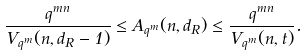Convert formula to latex. <formula><loc_0><loc_0><loc_500><loc_500>\frac { q ^ { m n } } { V _ { q ^ { m } } ( n , d _ { R } - 1 ) } \leq A _ { q ^ { m } } ( n , d _ { R } ) \leq \frac { q ^ { m n } } { V _ { q ^ { m } } ( n , t ) } .</formula> 